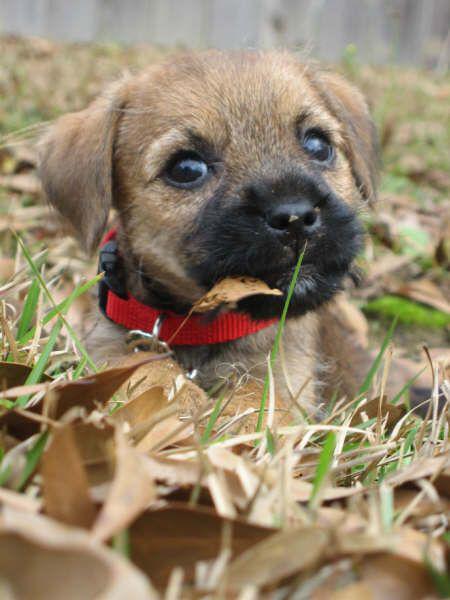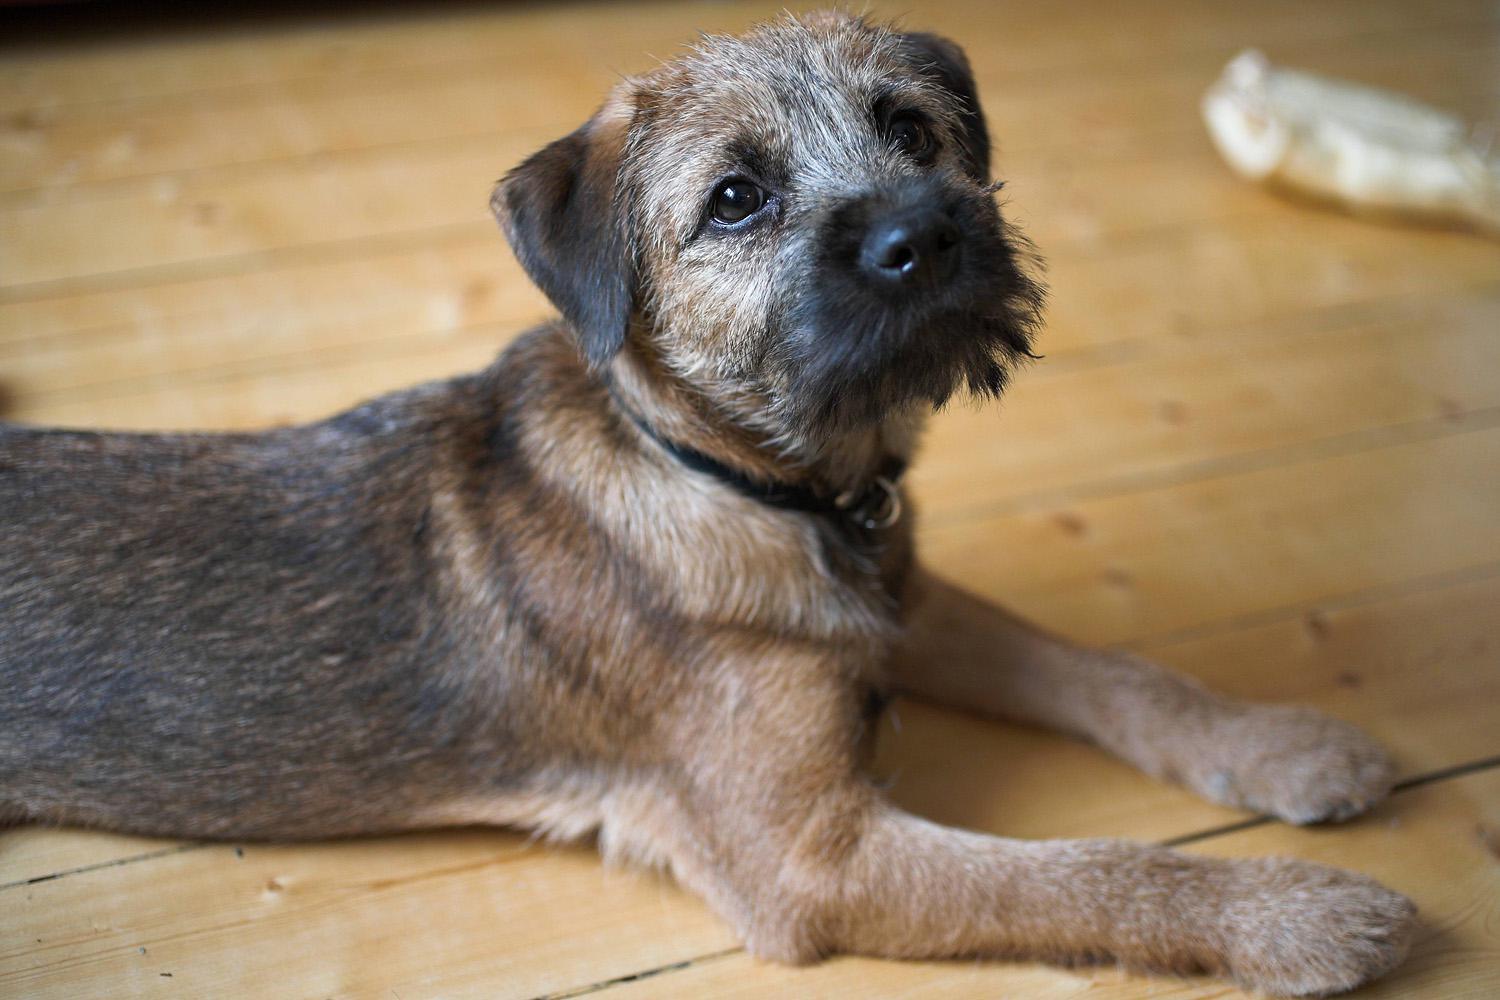The first image is the image on the left, the second image is the image on the right. For the images shown, is this caption "There are two dogs" true? Answer yes or no. Yes. The first image is the image on the left, the second image is the image on the right. Examine the images to the left and right. Is the description "All of the images contain only one dog." accurate? Answer yes or no. Yes. 